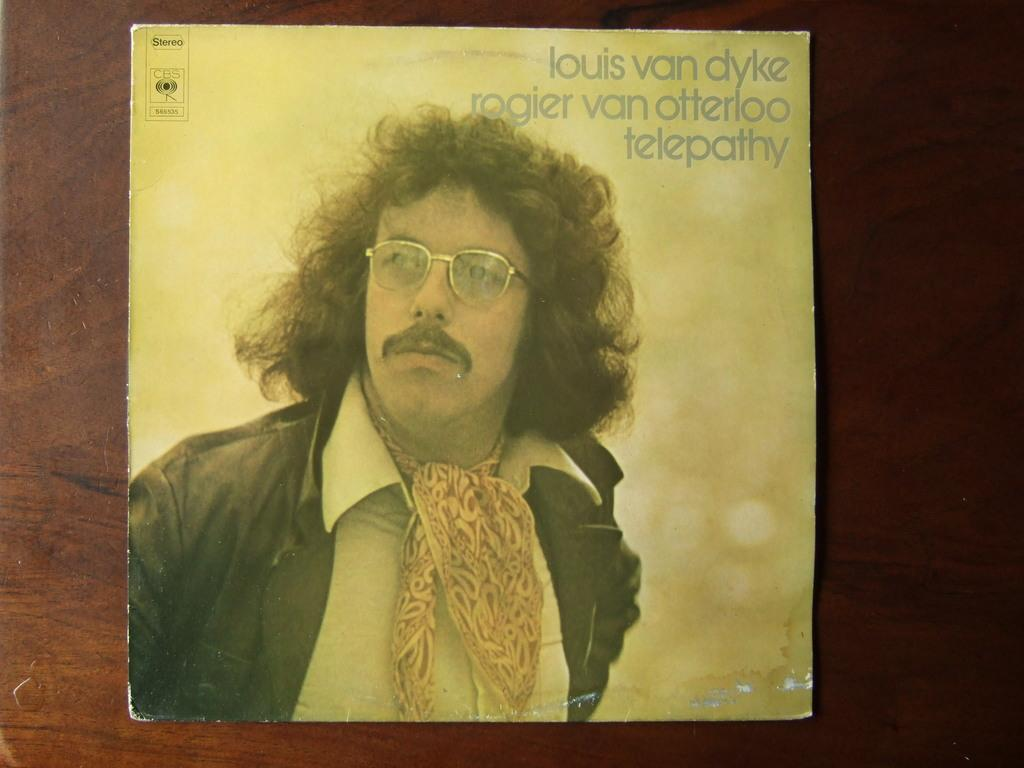What is the main object in the picture? There is a cardboard in the picture. What is depicted on the cardboard? The cardboard has a picture of a person on it. What is the person in the picture wearing? The person in the picture is wearing a black jacket. What can be seen above the picture on the cardboard? There is something written above the picture on the cardboard. What effect did the earthquake have on the cardboard in the image? There is no mention of an earthquake in the image or the provided facts, so we cannot determine its effect on the cardboard. 